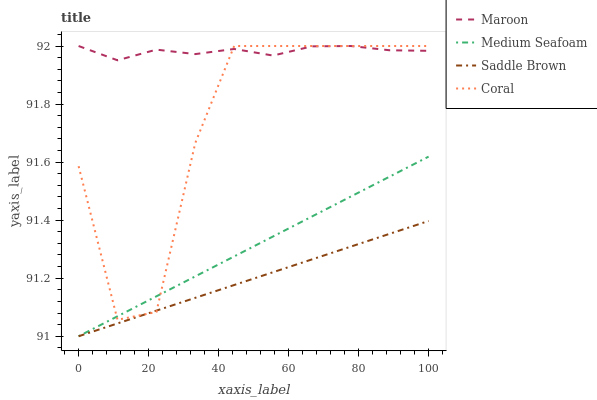Does Medium Seafoam have the minimum area under the curve?
Answer yes or no. No. Does Medium Seafoam have the maximum area under the curve?
Answer yes or no. No. Is Medium Seafoam the smoothest?
Answer yes or no. No. Is Medium Seafoam the roughest?
Answer yes or no. No. Does Maroon have the lowest value?
Answer yes or no. No. Does Medium Seafoam have the highest value?
Answer yes or no. No. Is Medium Seafoam less than Maroon?
Answer yes or no. Yes. Is Maroon greater than Saddle Brown?
Answer yes or no. Yes. Does Medium Seafoam intersect Maroon?
Answer yes or no. No. 